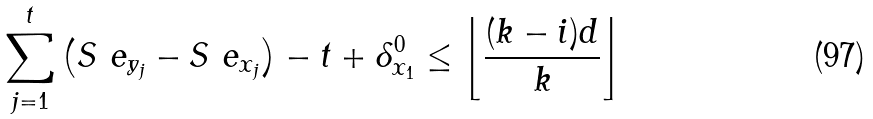Convert formula to latex. <formula><loc_0><loc_0><loc_500><loc_500>\sum _ { j = 1 } ^ { t } \left ( S ^ { \ } e _ { y _ { j } } - S ^ { \ } e _ { x _ { j } } \right ) - t + \delta _ { x _ { 1 } } ^ { 0 } \leq \left \lfloor \frac { ( k - i ) d } k \right \rfloor</formula> 